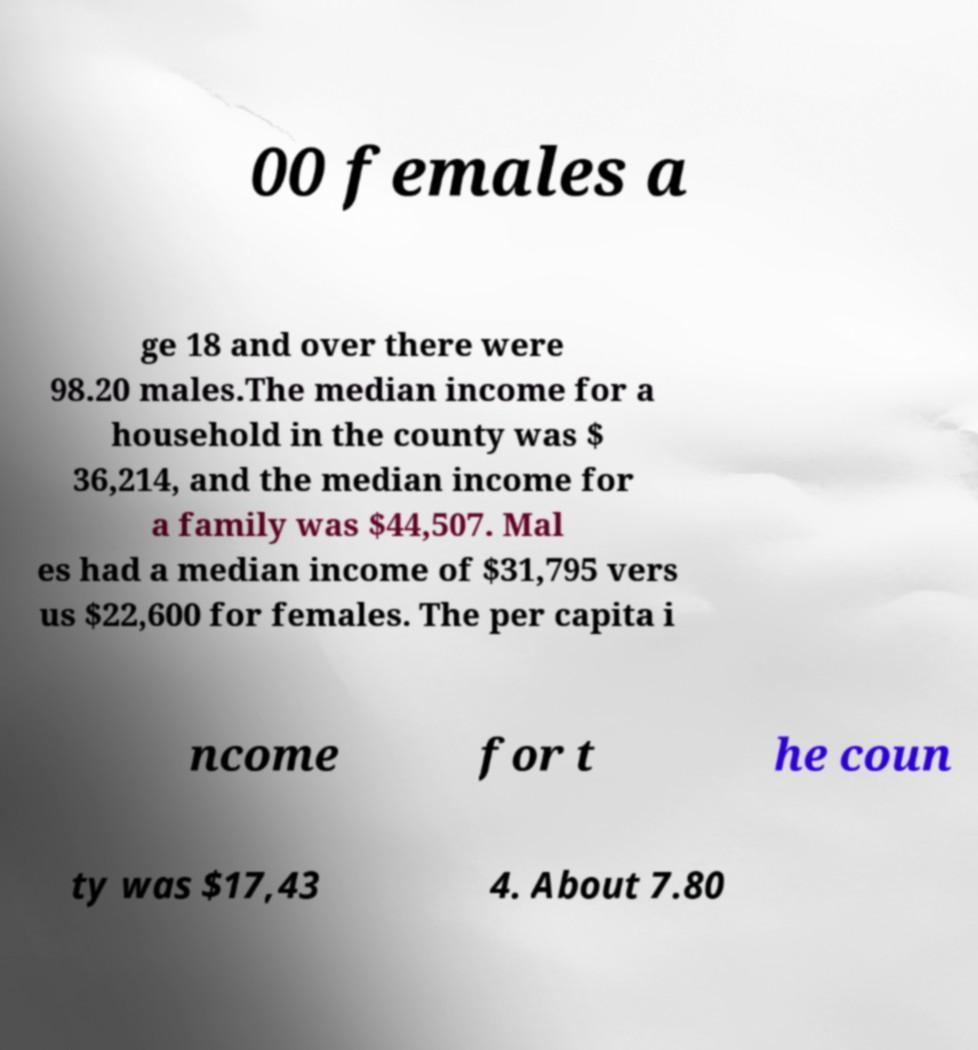Can you read and provide the text displayed in the image?This photo seems to have some interesting text. Can you extract and type it out for me? 00 females a ge 18 and over there were 98.20 males.The median income for a household in the county was $ 36,214, and the median income for a family was $44,507. Mal es had a median income of $31,795 vers us $22,600 for females. The per capita i ncome for t he coun ty was $17,43 4. About 7.80 